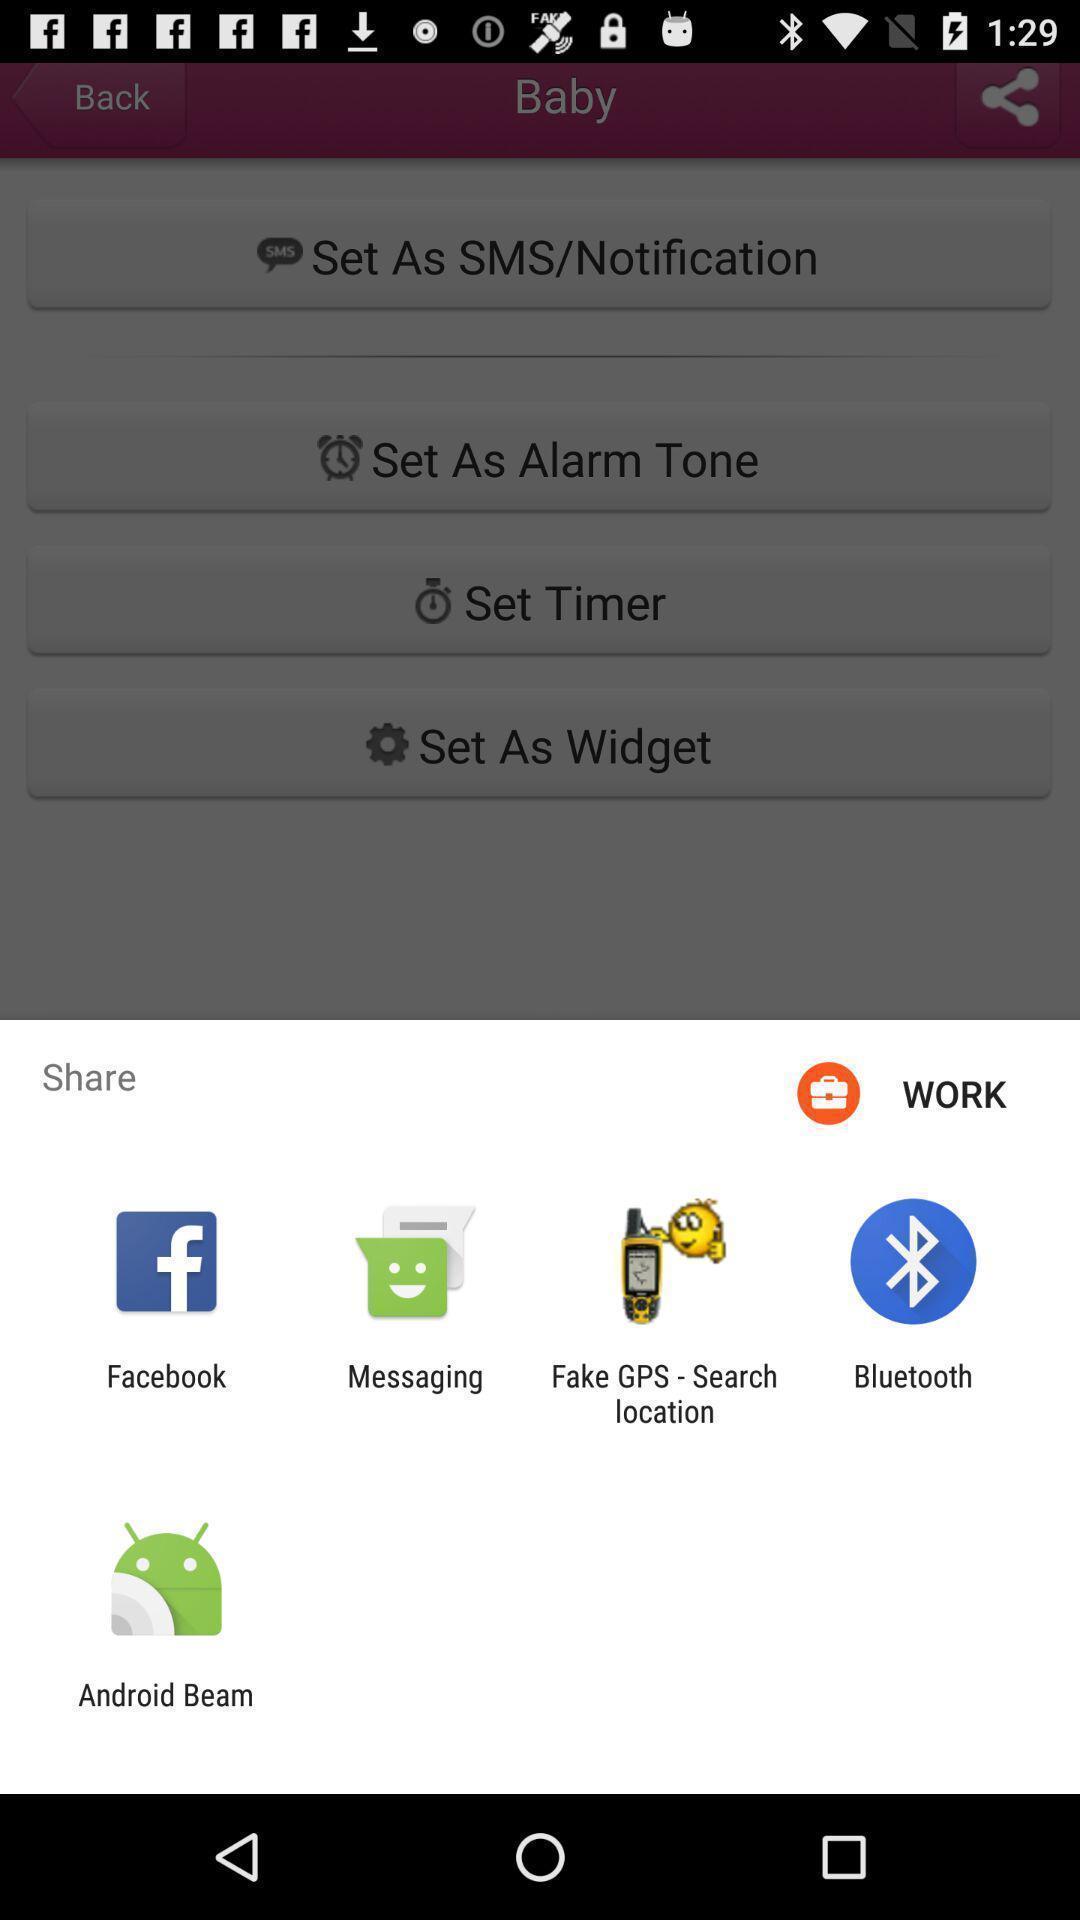Provide a description of this screenshot. Pop-up shows share option with multiple social applications. 